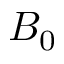<formula> <loc_0><loc_0><loc_500><loc_500>B _ { 0 }</formula> 